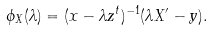Convert formula to latex. <formula><loc_0><loc_0><loc_500><loc_500>\phi _ { X } ( \lambda ) = ( x - \lambda { z } ^ { t } ) ^ { - 1 } ( \lambda X ^ { \prime } - { y } ) .</formula> 